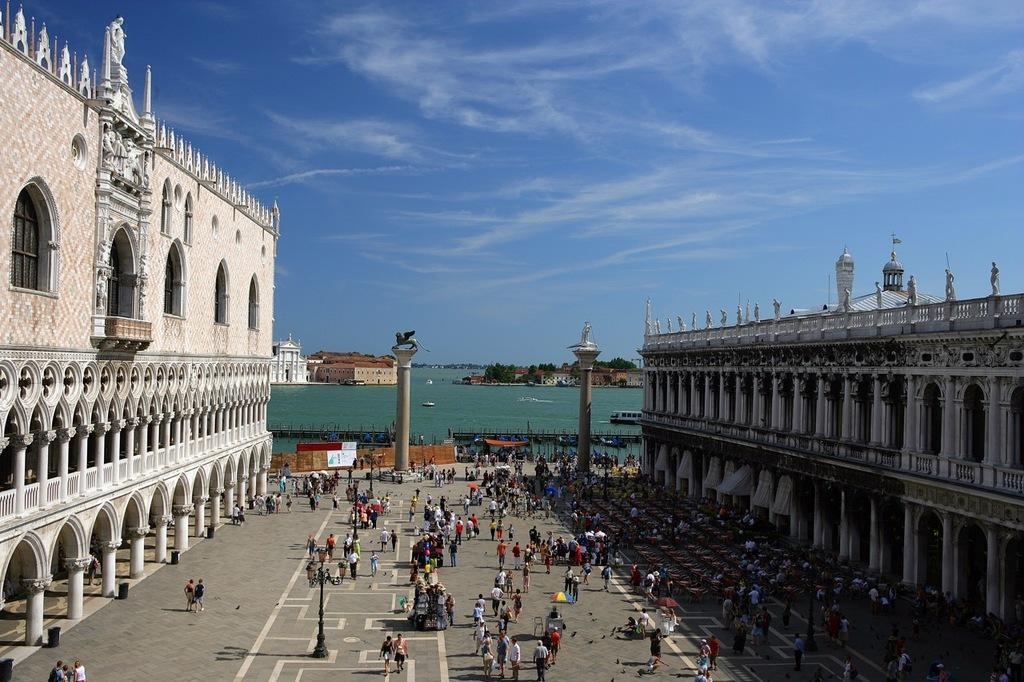How would you summarize this image in a sentence or two? In the center of the image we can see a few people are standing, few people are walking and a few people are holding some objects. In the background, we can see the sky, clouds, trees, water, poles, buildings, pillars, sculptures, one flag, umbrellas and a few other objects. 